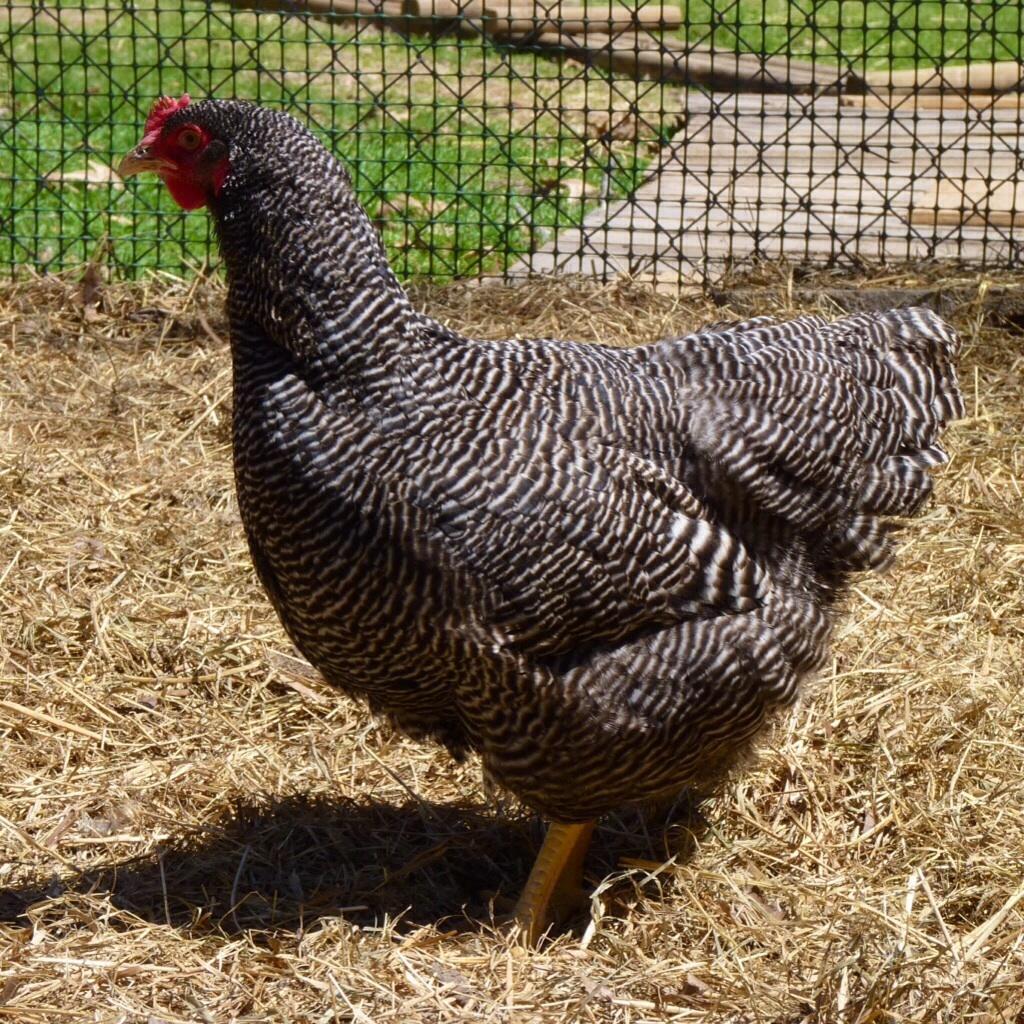Describe this image in one or two sentences. In this picture there is hung in the center of the image, on the dried grass floor and there is greenery and net at the top side of the image. 